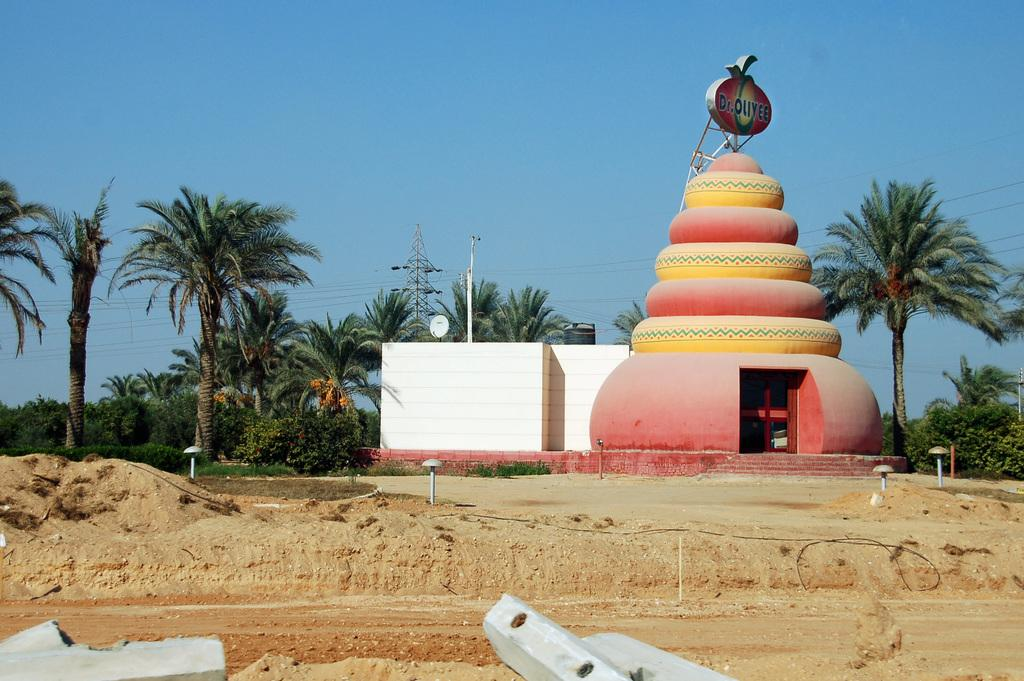What type of vegetation can be seen in the image? There are trees in the image. What tall structure is present in the image? There is a transmission tower in the image. What type of lighting is present in the image? There is a pole light and lights on the ground in the image. What is the color of the sky in the image? The sky is blue in the image. What type of man-made structure is visible in the image? There is a building in the image. What type of stew is being cooked in the image? There is no stew present in the image; it features trees, a transmission tower, a pole light, a blue sky, a building, and lights on the ground. Can you tell me how many times your dad appears in the image? There is no person, including your dad, present in the image. 